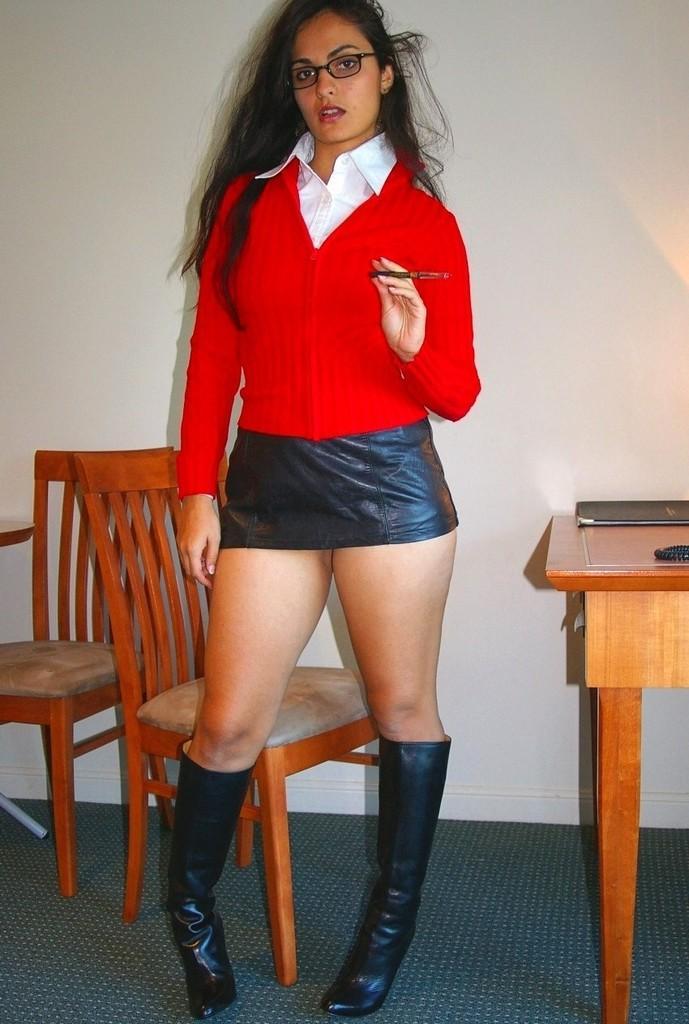Please provide a concise description of this image. In the image a woman is standing and holding a pen. Behind her there are some chairs and table, on the table there are some books and there is a wall. 